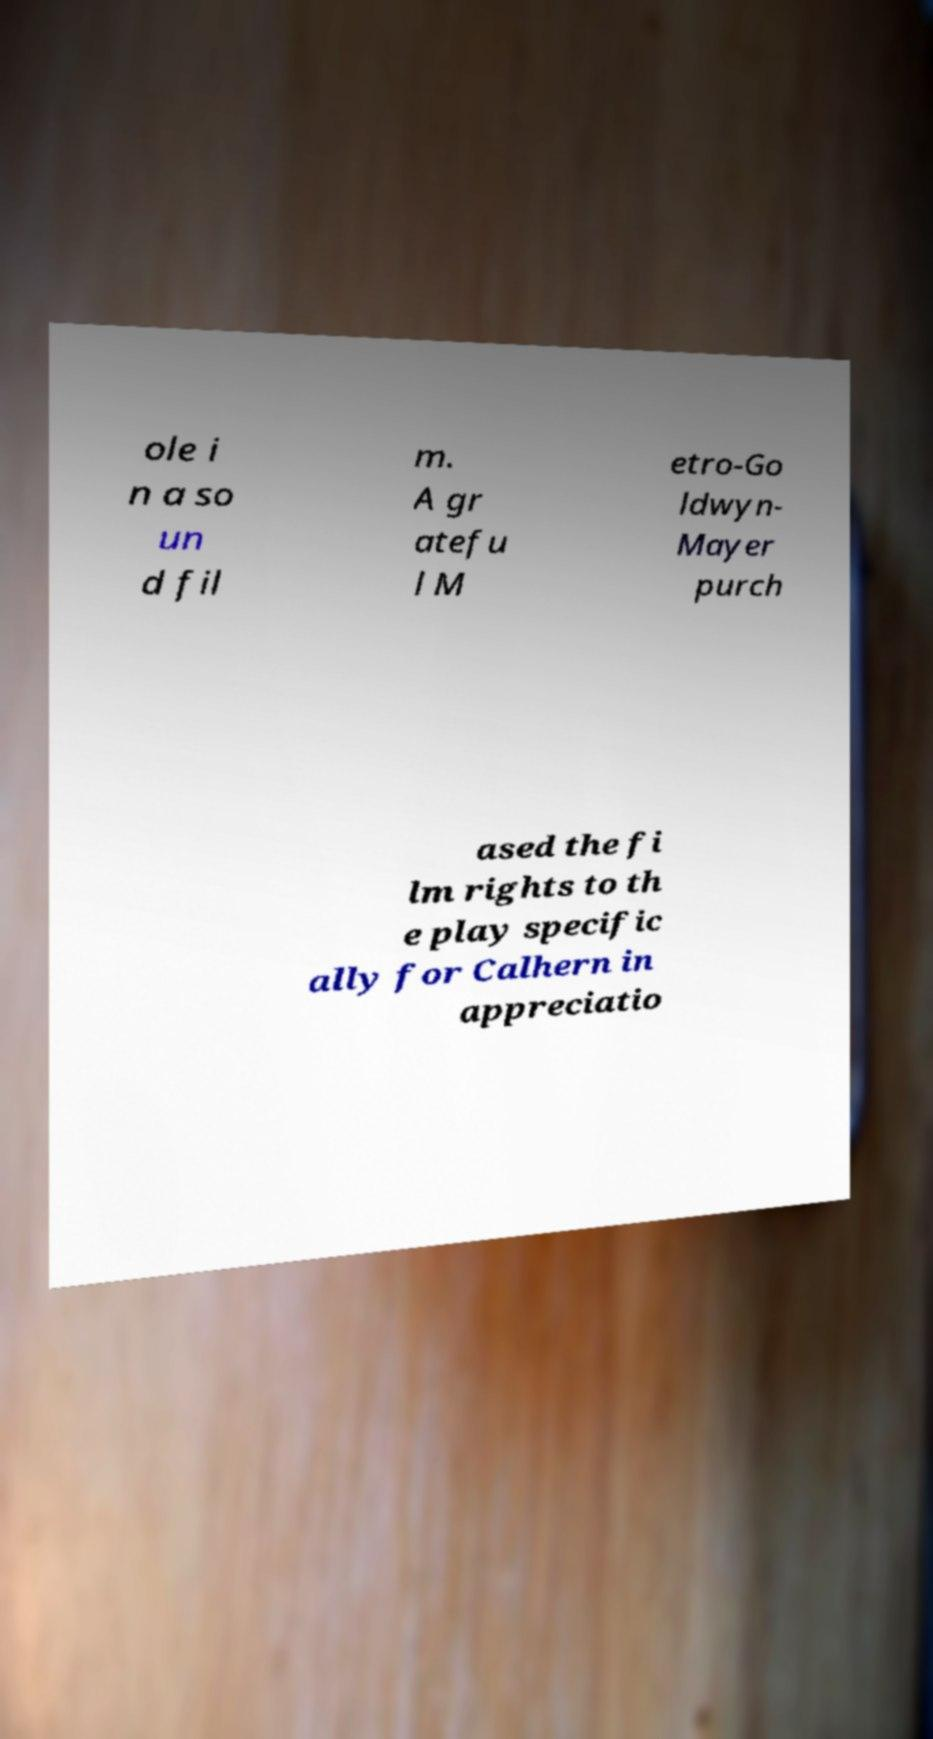What messages or text are displayed in this image? I need them in a readable, typed format. ole i n a so un d fil m. A gr atefu l M etro-Go ldwyn- Mayer purch ased the fi lm rights to th e play specific ally for Calhern in appreciatio 